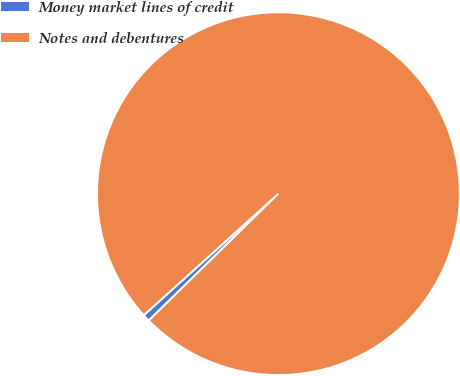Convert chart to OTSL. <chart><loc_0><loc_0><loc_500><loc_500><pie_chart><fcel>Money market lines of credit<fcel>Notes and debentures<nl><fcel>0.64%<fcel>99.36%<nl></chart> 